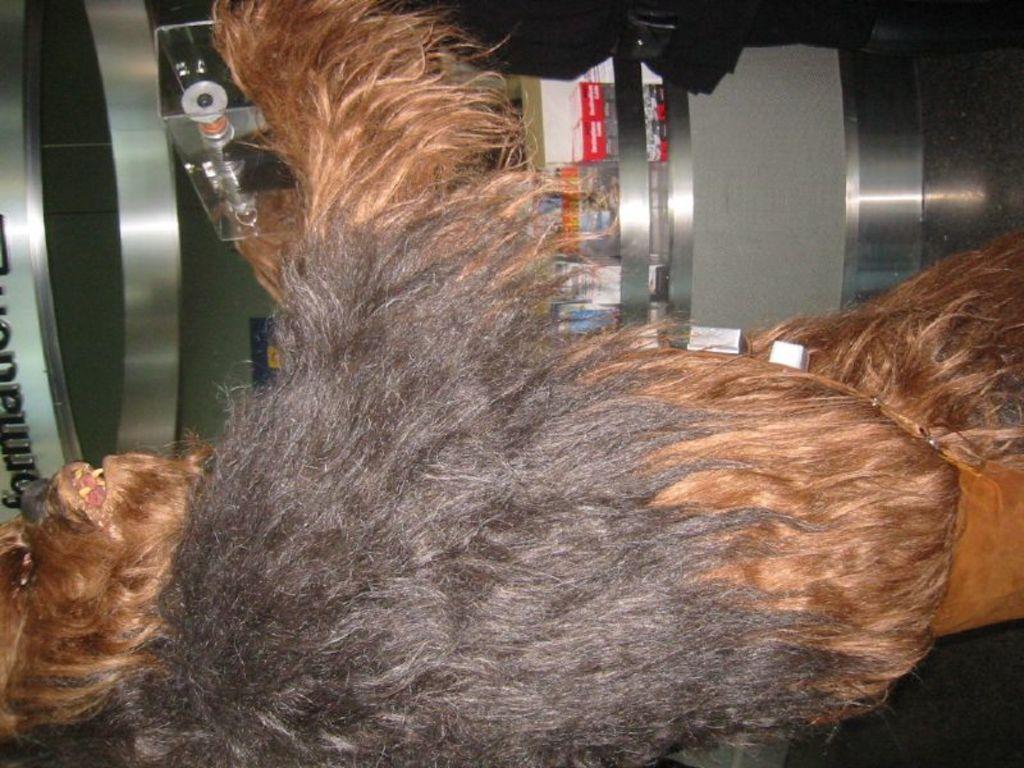Describe this image in one or two sentences. At the bottom of the picture, the animal in black and brown fur is holding something in its hand. Beside that, we see a building and a glass door from which we can see a red color board. This board is placed on the white wall. This picture might be clicked in the dark. 